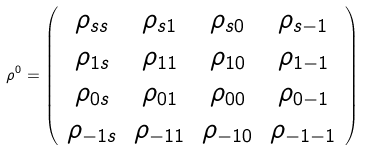Convert formula to latex. <formula><loc_0><loc_0><loc_500><loc_500>\rho ^ { 0 } = \left ( \begin{array} { c c c c } \rho _ { s s } & \rho _ { s 1 } & \rho _ { s 0 } & \rho _ { s - 1 } \\ \rho _ { 1 s } & \rho _ { 1 1 } & \rho _ { 1 0 } & \rho _ { 1 - 1 } \\ \rho _ { 0 s } & \rho _ { 0 1 } & \rho _ { 0 0 } & \rho _ { 0 - 1 } \\ \rho _ { - 1 s } & \rho _ { - 1 1 } & \rho _ { - 1 0 } & \rho _ { - 1 - 1 } \\ \end{array} \right )</formula> 